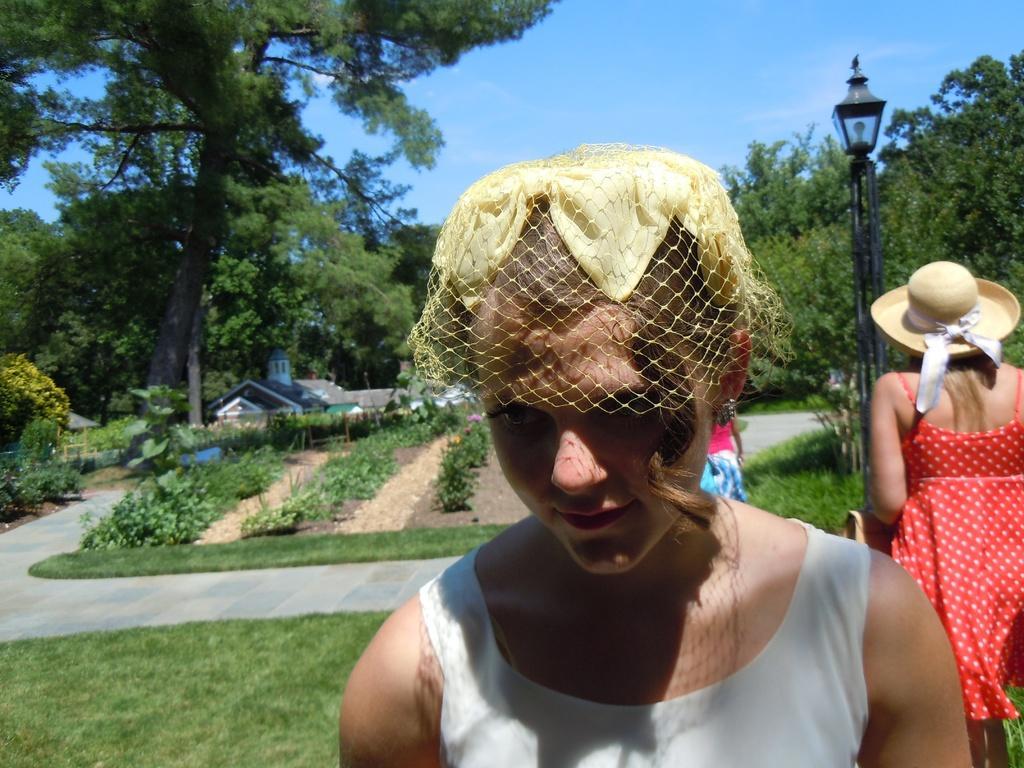Describe this image in one or two sentences. In this picture we can see group of people, on the right side of the image we can see a woman, she wore a cap, in the background we can see grass, few plants, trees, light, metal rod and houses. 